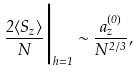Convert formula to latex. <formula><loc_0><loc_0><loc_500><loc_500>\frac { 2 \langle S _ { z } \rangle } { N } \Big { | } _ { h = 1 } \sim \frac { a _ { z } ^ { \left ( 0 \right ) } } { N ^ { 2 / 3 } } ,</formula> 